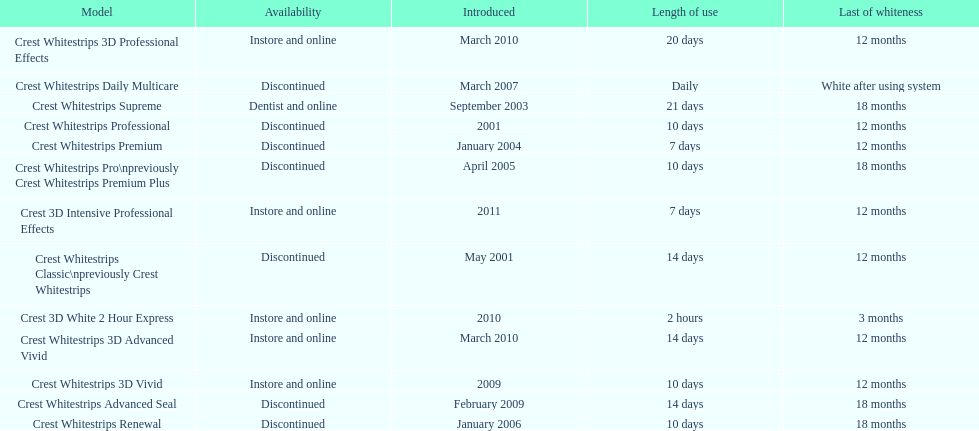Is each white strip discontinued? No. 